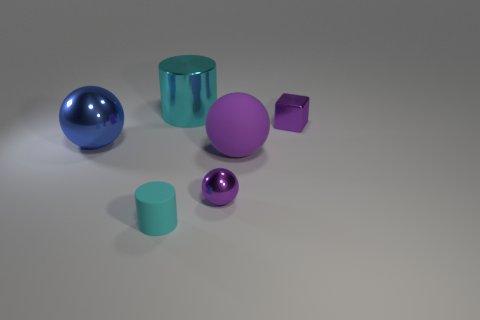Is there a tiny shiny object of the same color as the metal cube?
Your answer should be very brief. Yes. There is a tiny purple metallic object in front of the tiny purple shiny block; is it the same shape as the blue thing?
Your answer should be very brief. Yes. How many purple shiny balls are the same size as the cyan rubber cylinder?
Keep it short and to the point. 1. How many big spheres are to the right of the small object that is on the right side of the big purple rubber thing?
Provide a succinct answer. 0. Are the small purple thing that is in front of the large blue shiny object and the blue ball made of the same material?
Offer a very short reply. Yes. Do the cylinder that is behind the small purple metal cube and the cylinder to the left of the big cyan thing have the same material?
Your answer should be compact. No. Is the number of large objects that are in front of the purple shiny cube greater than the number of large cylinders?
Give a very brief answer. Yes. There is a big object in front of the metal ball behind the big matte thing; what is its color?
Keep it short and to the point. Purple. The cyan metallic object that is the same size as the rubber ball is what shape?
Make the answer very short. Cylinder. There is a large metallic object that is the same color as the small matte cylinder; what shape is it?
Provide a succinct answer. Cylinder. 